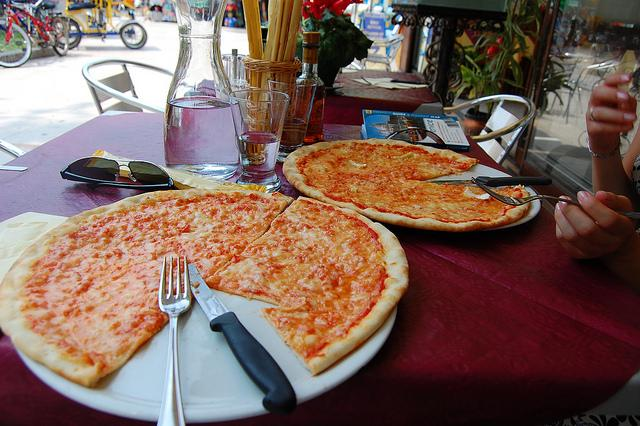What color is the vase in the middle of the table surrounded by pizzas? Please explain your reasoning. clear. There is clear water in a glass pitcher which glass is see thru and able to see what is inside it. 